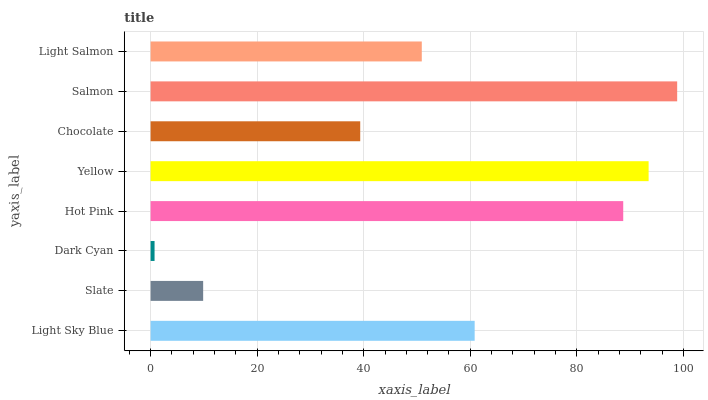Is Dark Cyan the minimum?
Answer yes or no. Yes. Is Salmon the maximum?
Answer yes or no. Yes. Is Slate the minimum?
Answer yes or no. No. Is Slate the maximum?
Answer yes or no. No. Is Light Sky Blue greater than Slate?
Answer yes or no. Yes. Is Slate less than Light Sky Blue?
Answer yes or no. Yes. Is Slate greater than Light Sky Blue?
Answer yes or no. No. Is Light Sky Blue less than Slate?
Answer yes or no. No. Is Light Sky Blue the high median?
Answer yes or no. Yes. Is Light Salmon the low median?
Answer yes or no. Yes. Is Light Salmon the high median?
Answer yes or no. No. Is Salmon the low median?
Answer yes or no. No. 